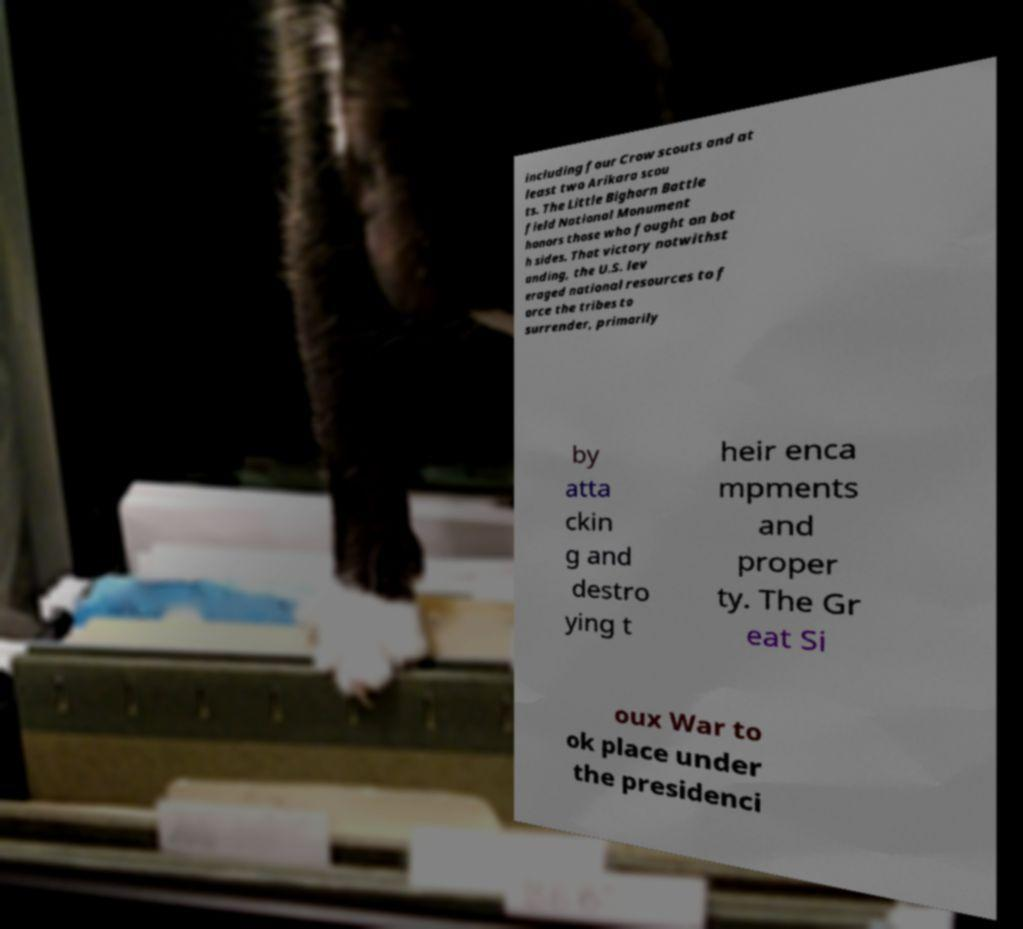Can you read and provide the text displayed in the image?This photo seems to have some interesting text. Can you extract and type it out for me? including four Crow scouts and at least two Arikara scou ts. The Little Bighorn Battle field National Monument honors those who fought on bot h sides. That victory notwithst anding, the U.S. lev eraged national resources to f orce the tribes to surrender, primarily by atta ckin g and destro ying t heir enca mpments and proper ty. The Gr eat Si oux War to ok place under the presidenci 